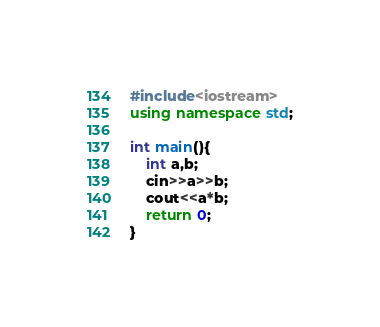<code> <loc_0><loc_0><loc_500><loc_500><_C++_>#include<iostream> 
using namespace std;

int main(){
    int a,b;
    cin>>a>>b;
    cout<<a*b;
    return 0;
}</code> 